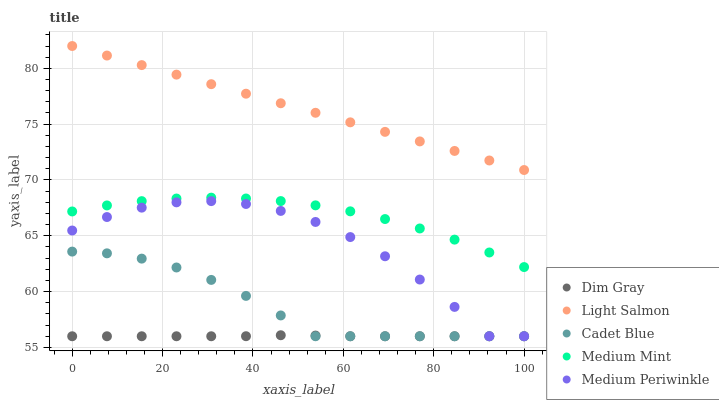Does Dim Gray have the minimum area under the curve?
Answer yes or no. Yes. Does Light Salmon have the maximum area under the curve?
Answer yes or no. Yes. Does Medium Mint have the minimum area under the curve?
Answer yes or no. No. Does Medium Mint have the maximum area under the curve?
Answer yes or no. No. Is Light Salmon the smoothest?
Answer yes or no. Yes. Is Medium Periwinkle the roughest?
Answer yes or no. Yes. Is Medium Mint the smoothest?
Answer yes or no. No. Is Medium Mint the roughest?
Answer yes or no. No. Does Cadet Blue have the lowest value?
Answer yes or no. Yes. Does Medium Mint have the lowest value?
Answer yes or no. No. Does Light Salmon have the highest value?
Answer yes or no. Yes. Does Medium Mint have the highest value?
Answer yes or no. No. Is Dim Gray less than Medium Mint?
Answer yes or no. Yes. Is Light Salmon greater than Cadet Blue?
Answer yes or no. Yes. Does Medium Periwinkle intersect Cadet Blue?
Answer yes or no. Yes. Is Medium Periwinkle less than Cadet Blue?
Answer yes or no. No. Is Medium Periwinkle greater than Cadet Blue?
Answer yes or no. No. Does Dim Gray intersect Medium Mint?
Answer yes or no. No. 